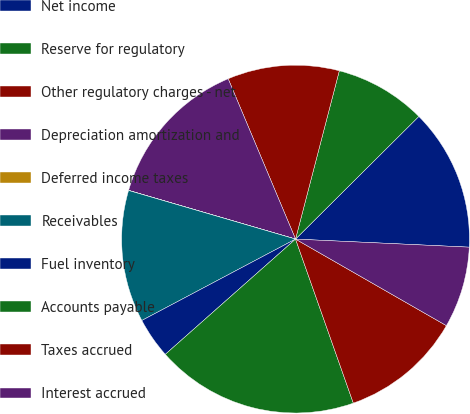<chart> <loc_0><loc_0><loc_500><loc_500><pie_chart><fcel>Net income<fcel>Reserve for regulatory<fcel>Other regulatory charges - net<fcel>Depreciation amortization and<fcel>Deferred income taxes<fcel>Receivables<fcel>Fuel inventory<fcel>Accounts payable<fcel>Taxes accrued<fcel>Interest accrued<nl><fcel>13.2%<fcel>8.49%<fcel>10.38%<fcel>14.15%<fcel>0.01%<fcel>12.26%<fcel>3.78%<fcel>18.86%<fcel>11.32%<fcel>7.55%<nl></chart> 